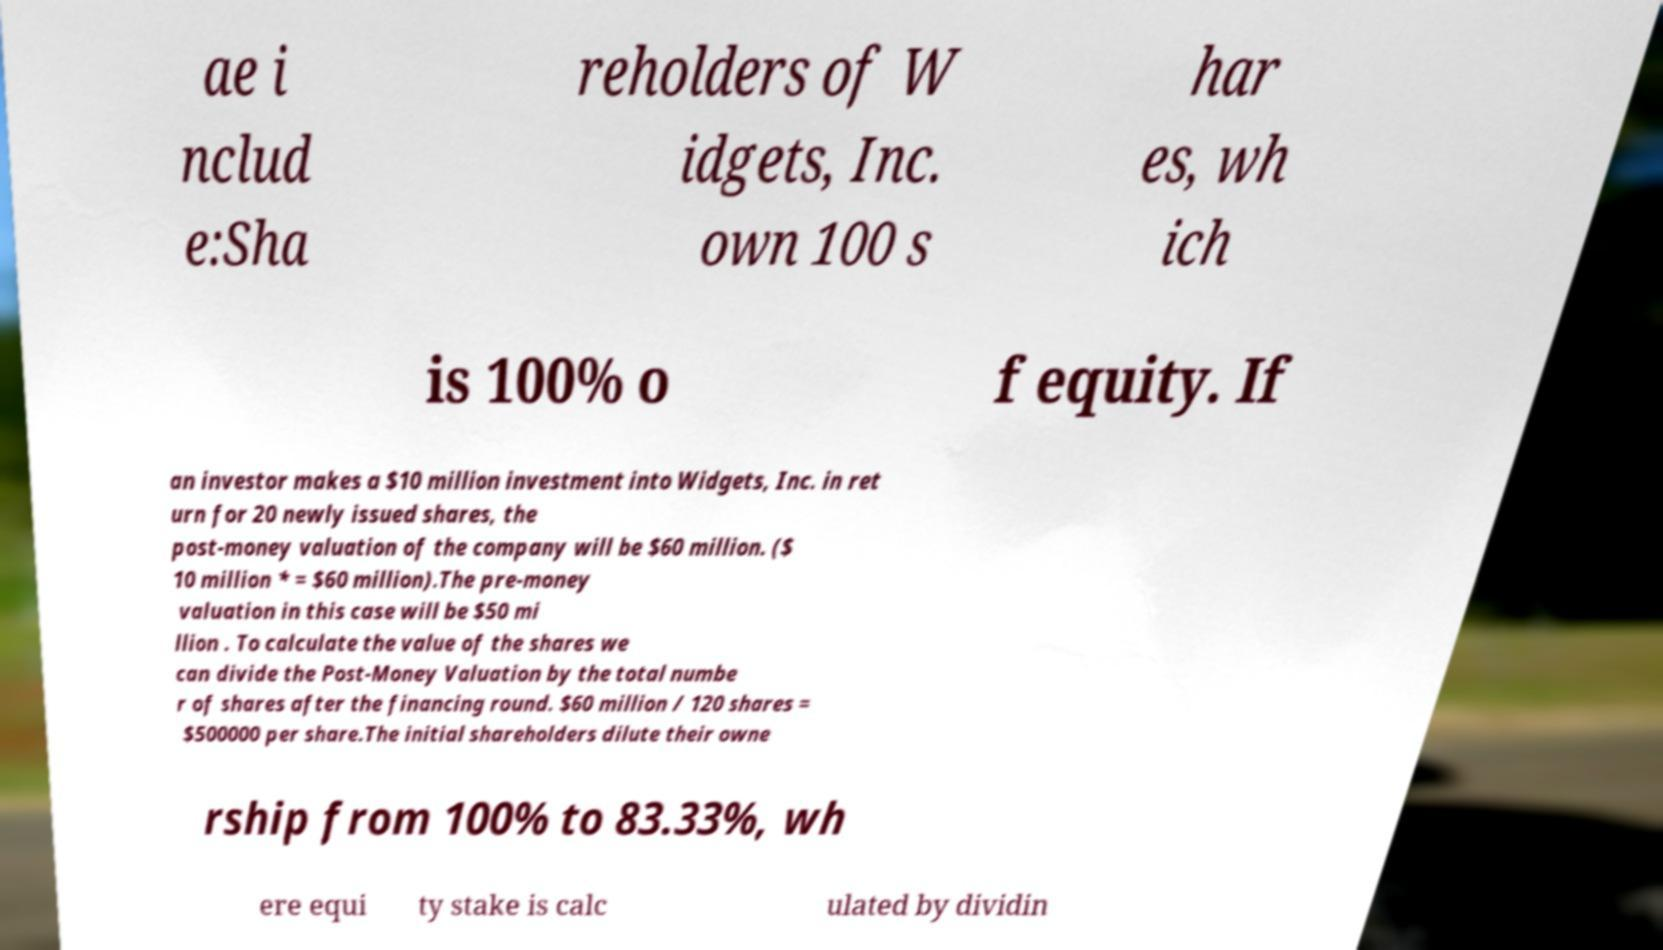What messages or text are displayed in this image? I need them in a readable, typed format. ae i nclud e:Sha reholders of W idgets, Inc. own 100 s har es, wh ich is 100% o f equity. If an investor makes a $10 million investment into Widgets, Inc. in ret urn for 20 newly issued shares, the post-money valuation of the company will be $60 million. ($ 10 million * = $60 million).The pre-money valuation in this case will be $50 mi llion . To calculate the value of the shares we can divide the Post-Money Valuation by the total numbe r of shares after the financing round. $60 million / 120 shares = $500000 per share.The initial shareholders dilute their owne rship from 100% to 83.33%, wh ere equi ty stake is calc ulated by dividin 